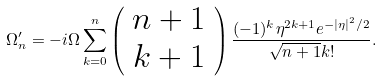Convert formula to latex. <formula><loc_0><loc_0><loc_500><loc_500>\Omega _ { n } ^ { \prime } = - i \Omega \sum _ { k = 0 } ^ { n } \left ( \begin{array} { c } n + 1 \\ k + 1 \end{array} \right ) \frac { ( - 1 ) ^ { k } \eta ^ { 2 k + 1 } e ^ { - | \eta | ^ { 2 } / 2 } } { \sqrt { n + 1 } k ! } .</formula> 